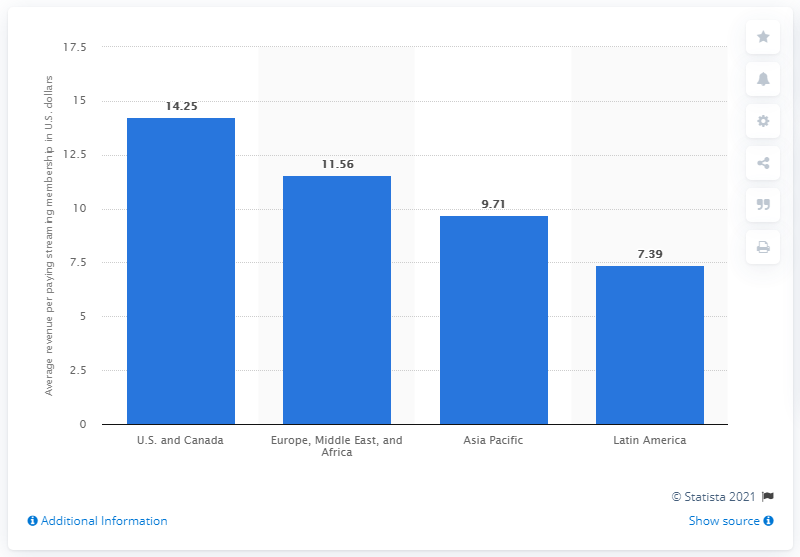Mention a couple of crucial points in this snapshot. The average monthly revenue per paying streaming customer in North America in 2021 was 14.25. The average monthly revenue for Latin American Netflix subscribers in the first quarter of 2021 was 7.39. 